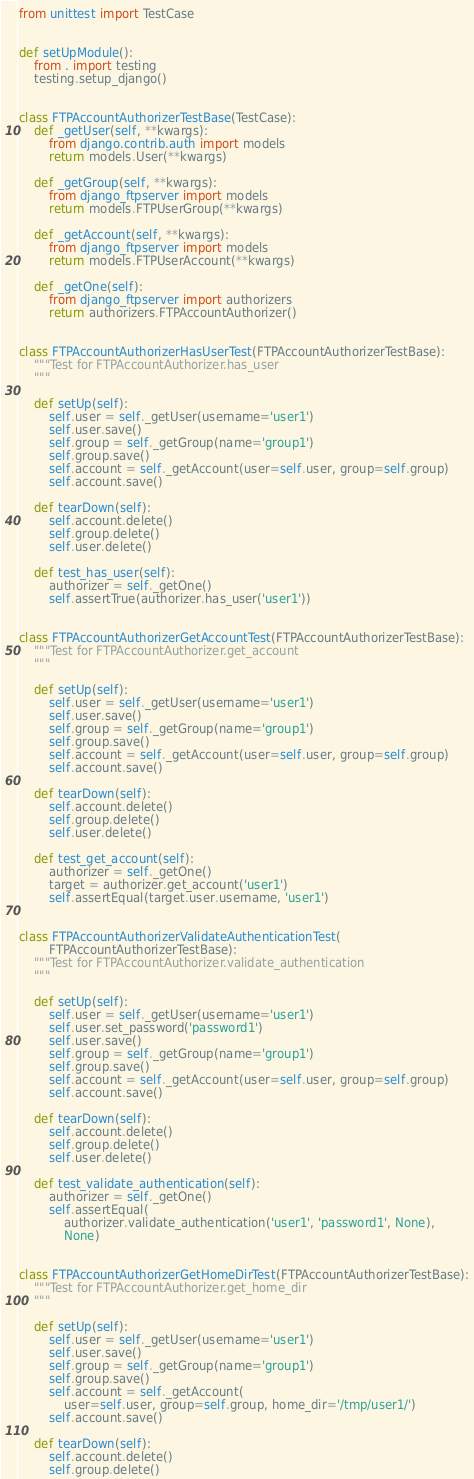<code> <loc_0><loc_0><loc_500><loc_500><_Python_>from unittest import TestCase


def setUpModule():
    from . import testing
    testing.setup_django()


class FTPAccountAuthorizerTestBase(TestCase):
    def _getUser(self, **kwargs):
        from django.contrib.auth import models
        return models.User(**kwargs)

    def _getGroup(self, **kwargs):
        from django_ftpserver import models
        return models.FTPUserGroup(**kwargs)

    def _getAccount(self, **kwargs):
        from django_ftpserver import models
        return models.FTPUserAccount(**kwargs)

    def _getOne(self):
        from django_ftpserver import authorizers
        return authorizers.FTPAccountAuthorizer()


class FTPAccountAuthorizerHasUserTest(FTPAccountAuthorizerTestBase):
    """Test for FTPAccountAuthorizer.has_user
    """

    def setUp(self):
        self.user = self._getUser(username='user1')
        self.user.save()
        self.group = self._getGroup(name='group1')
        self.group.save()
        self.account = self._getAccount(user=self.user, group=self.group)
        self.account.save()

    def tearDown(self):
        self.account.delete()
        self.group.delete()
        self.user.delete()

    def test_has_user(self):
        authorizer = self._getOne()
        self.assertTrue(authorizer.has_user('user1'))


class FTPAccountAuthorizerGetAccountTest(FTPAccountAuthorizerTestBase):
    """Test for FTPAccountAuthorizer.get_account
    """

    def setUp(self):
        self.user = self._getUser(username='user1')
        self.user.save()
        self.group = self._getGroup(name='group1')
        self.group.save()
        self.account = self._getAccount(user=self.user, group=self.group)
        self.account.save()

    def tearDown(self):
        self.account.delete()
        self.group.delete()
        self.user.delete()

    def test_get_account(self):
        authorizer = self._getOne()
        target = authorizer.get_account('user1')
        self.assertEqual(target.user.username, 'user1')


class FTPAccountAuthorizerValidateAuthenticationTest(
        FTPAccountAuthorizerTestBase):
    """Test for FTPAccountAuthorizer.validate_authentication
    """

    def setUp(self):
        self.user = self._getUser(username='user1')
        self.user.set_password('password1')
        self.user.save()
        self.group = self._getGroup(name='group1')
        self.group.save()
        self.account = self._getAccount(user=self.user, group=self.group)
        self.account.save()

    def tearDown(self):
        self.account.delete()
        self.group.delete()
        self.user.delete()

    def test_validate_authentication(self):
        authorizer = self._getOne()
        self.assertEqual(
            authorizer.validate_authentication('user1', 'password1', None),
            None)


class FTPAccountAuthorizerGetHomeDirTest(FTPAccountAuthorizerTestBase):
    """Test for FTPAccountAuthorizer.get_home_dir
    """

    def setUp(self):
        self.user = self._getUser(username='user1')
        self.user.save()
        self.group = self._getGroup(name='group1')
        self.group.save()
        self.account = self._getAccount(
            user=self.user, group=self.group, home_dir='/tmp/user1/')
        self.account.save()

    def tearDown(self):
        self.account.delete()
        self.group.delete()</code> 